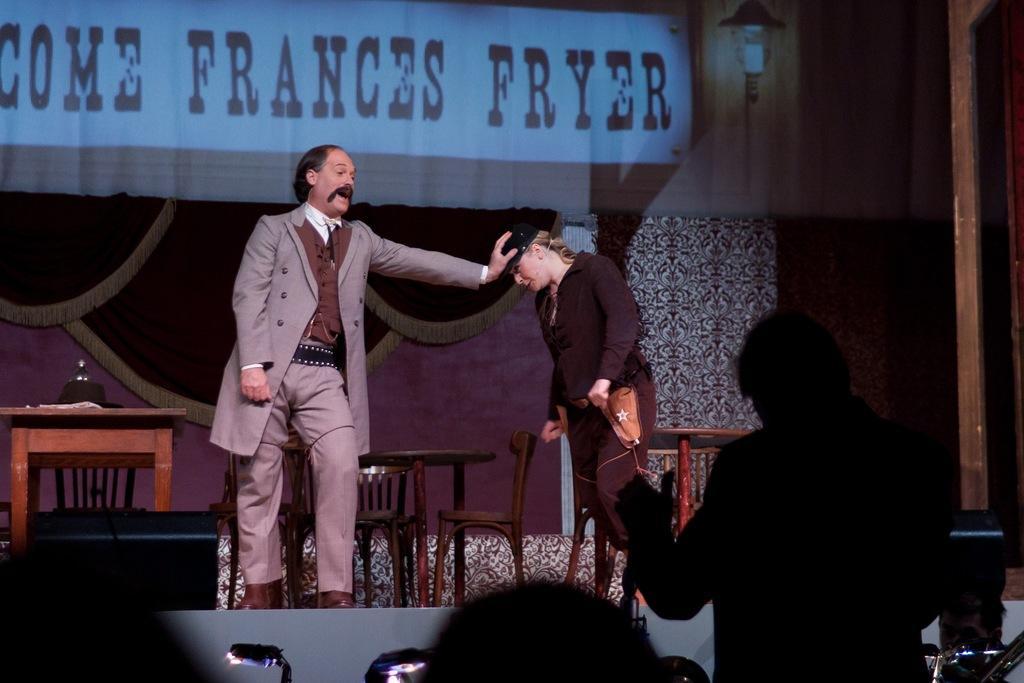In one or two sentences, can you explain what this image depicts? In this picture there is a man who is wearing suit, trouser and shoe. He is standing on the stage. Beside him there is a woman who is wearing cap, blazer, shirt and trouser. She is standing near to the tables and chairs. On the left i can see the papers on the table. At the top i can see the banner and light on the wall. At the bottom there is a man who is standing near to the lights and camera. 